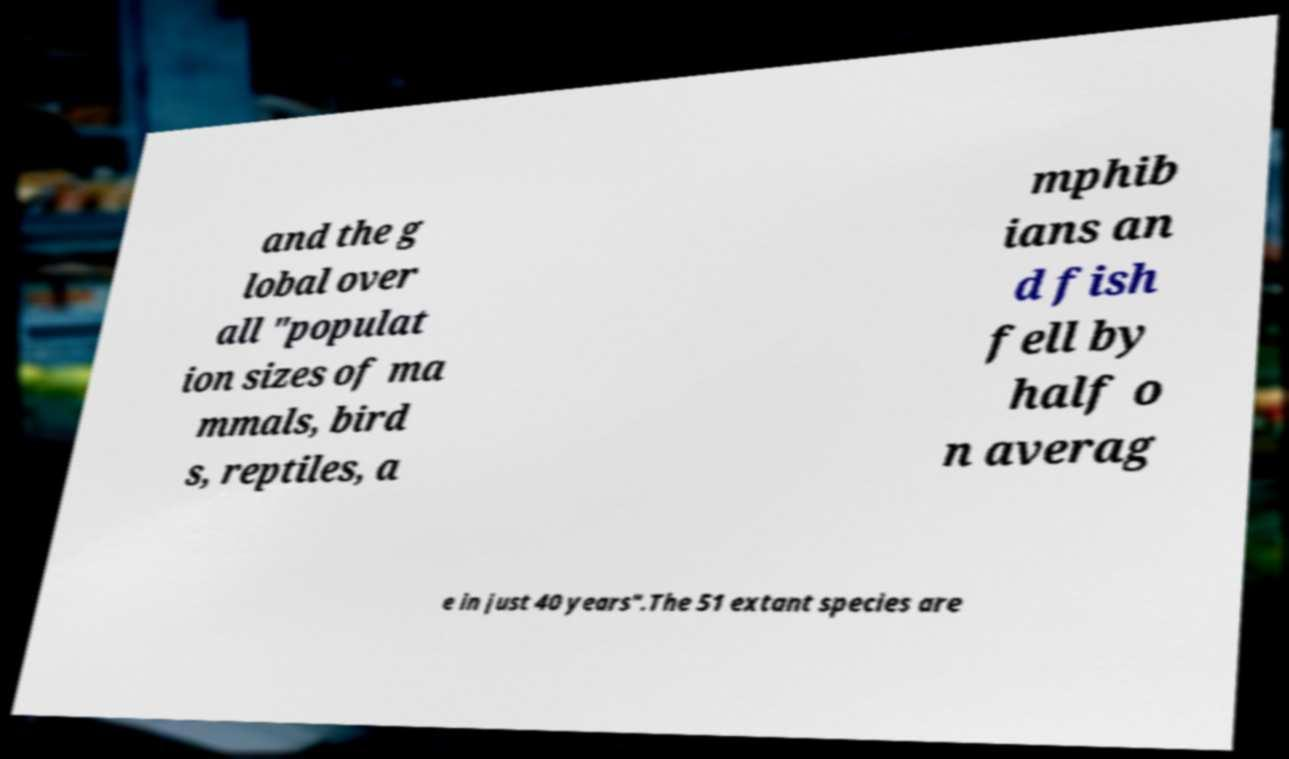What messages or text are displayed in this image? I need them in a readable, typed format. and the g lobal over all "populat ion sizes of ma mmals, bird s, reptiles, a mphib ians an d fish fell by half o n averag e in just 40 years".The 51 extant species are 